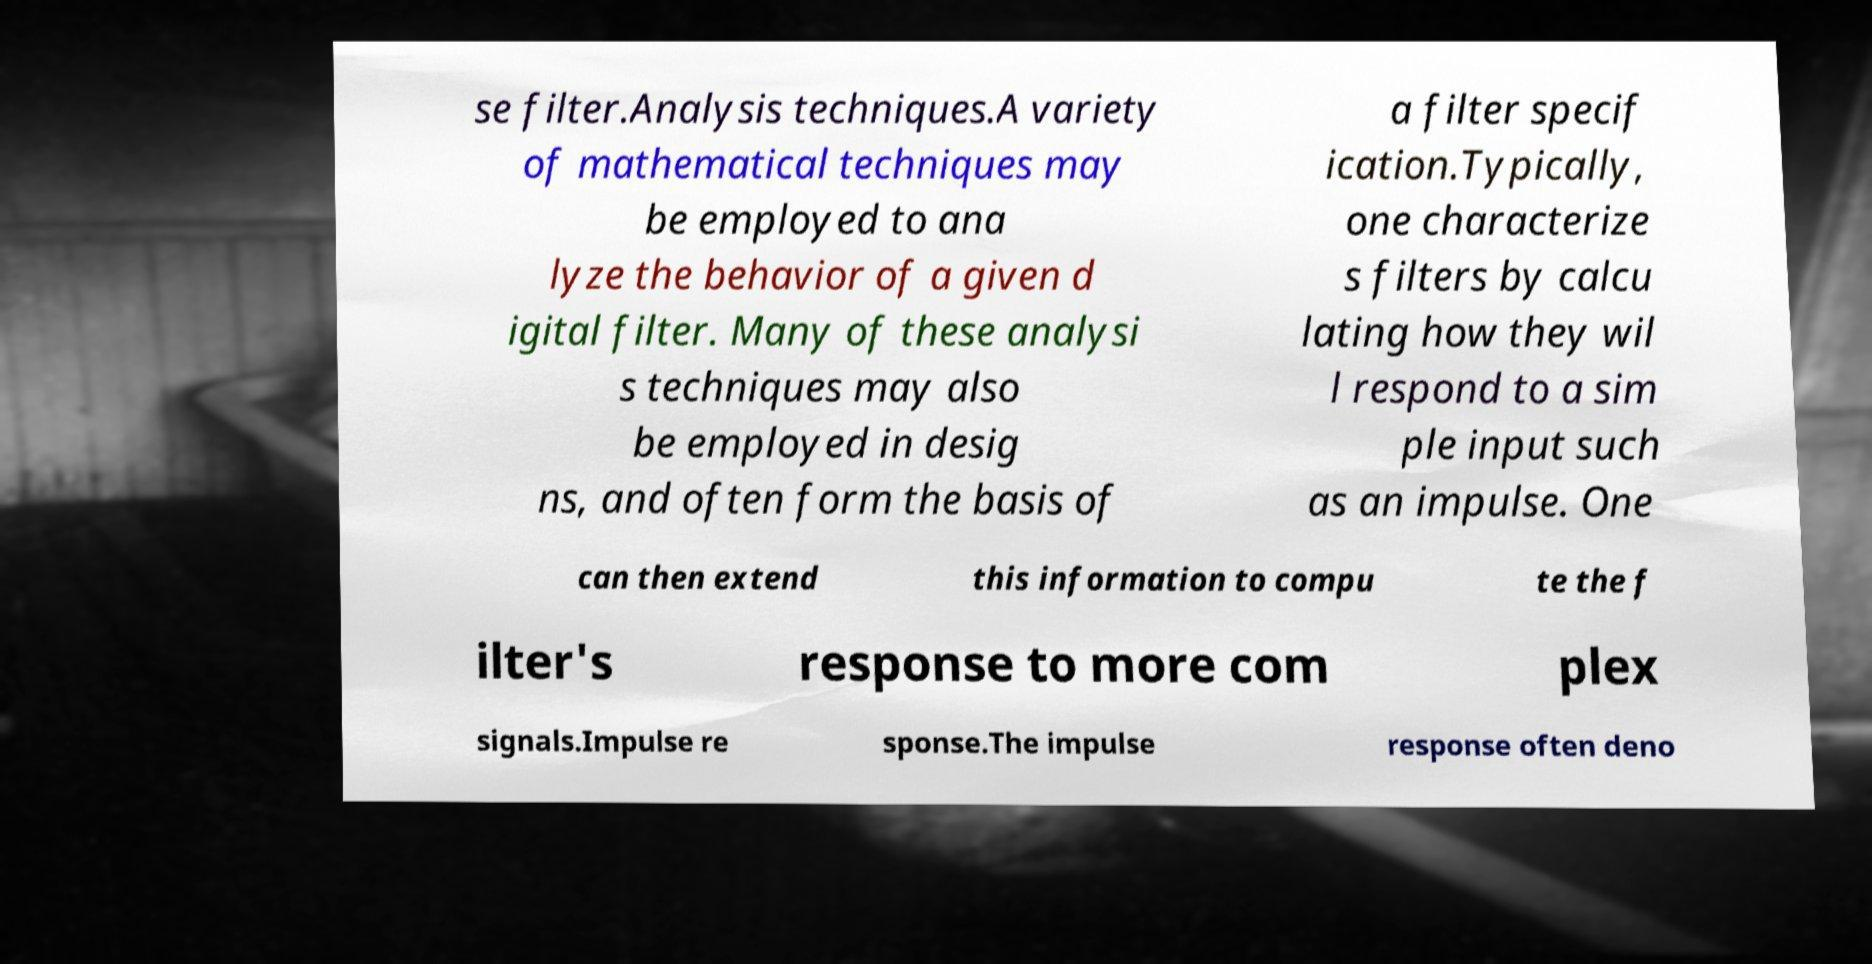I need the written content from this picture converted into text. Can you do that? se filter.Analysis techniques.A variety of mathematical techniques may be employed to ana lyze the behavior of a given d igital filter. Many of these analysi s techniques may also be employed in desig ns, and often form the basis of a filter specif ication.Typically, one characterize s filters by calcu lating how they wil l respond to a sim ple input such as an impulse. One can then extend this information to compu te the f ilter's response to more com plex signals.Impulse re sponse.The impulse response often deno 